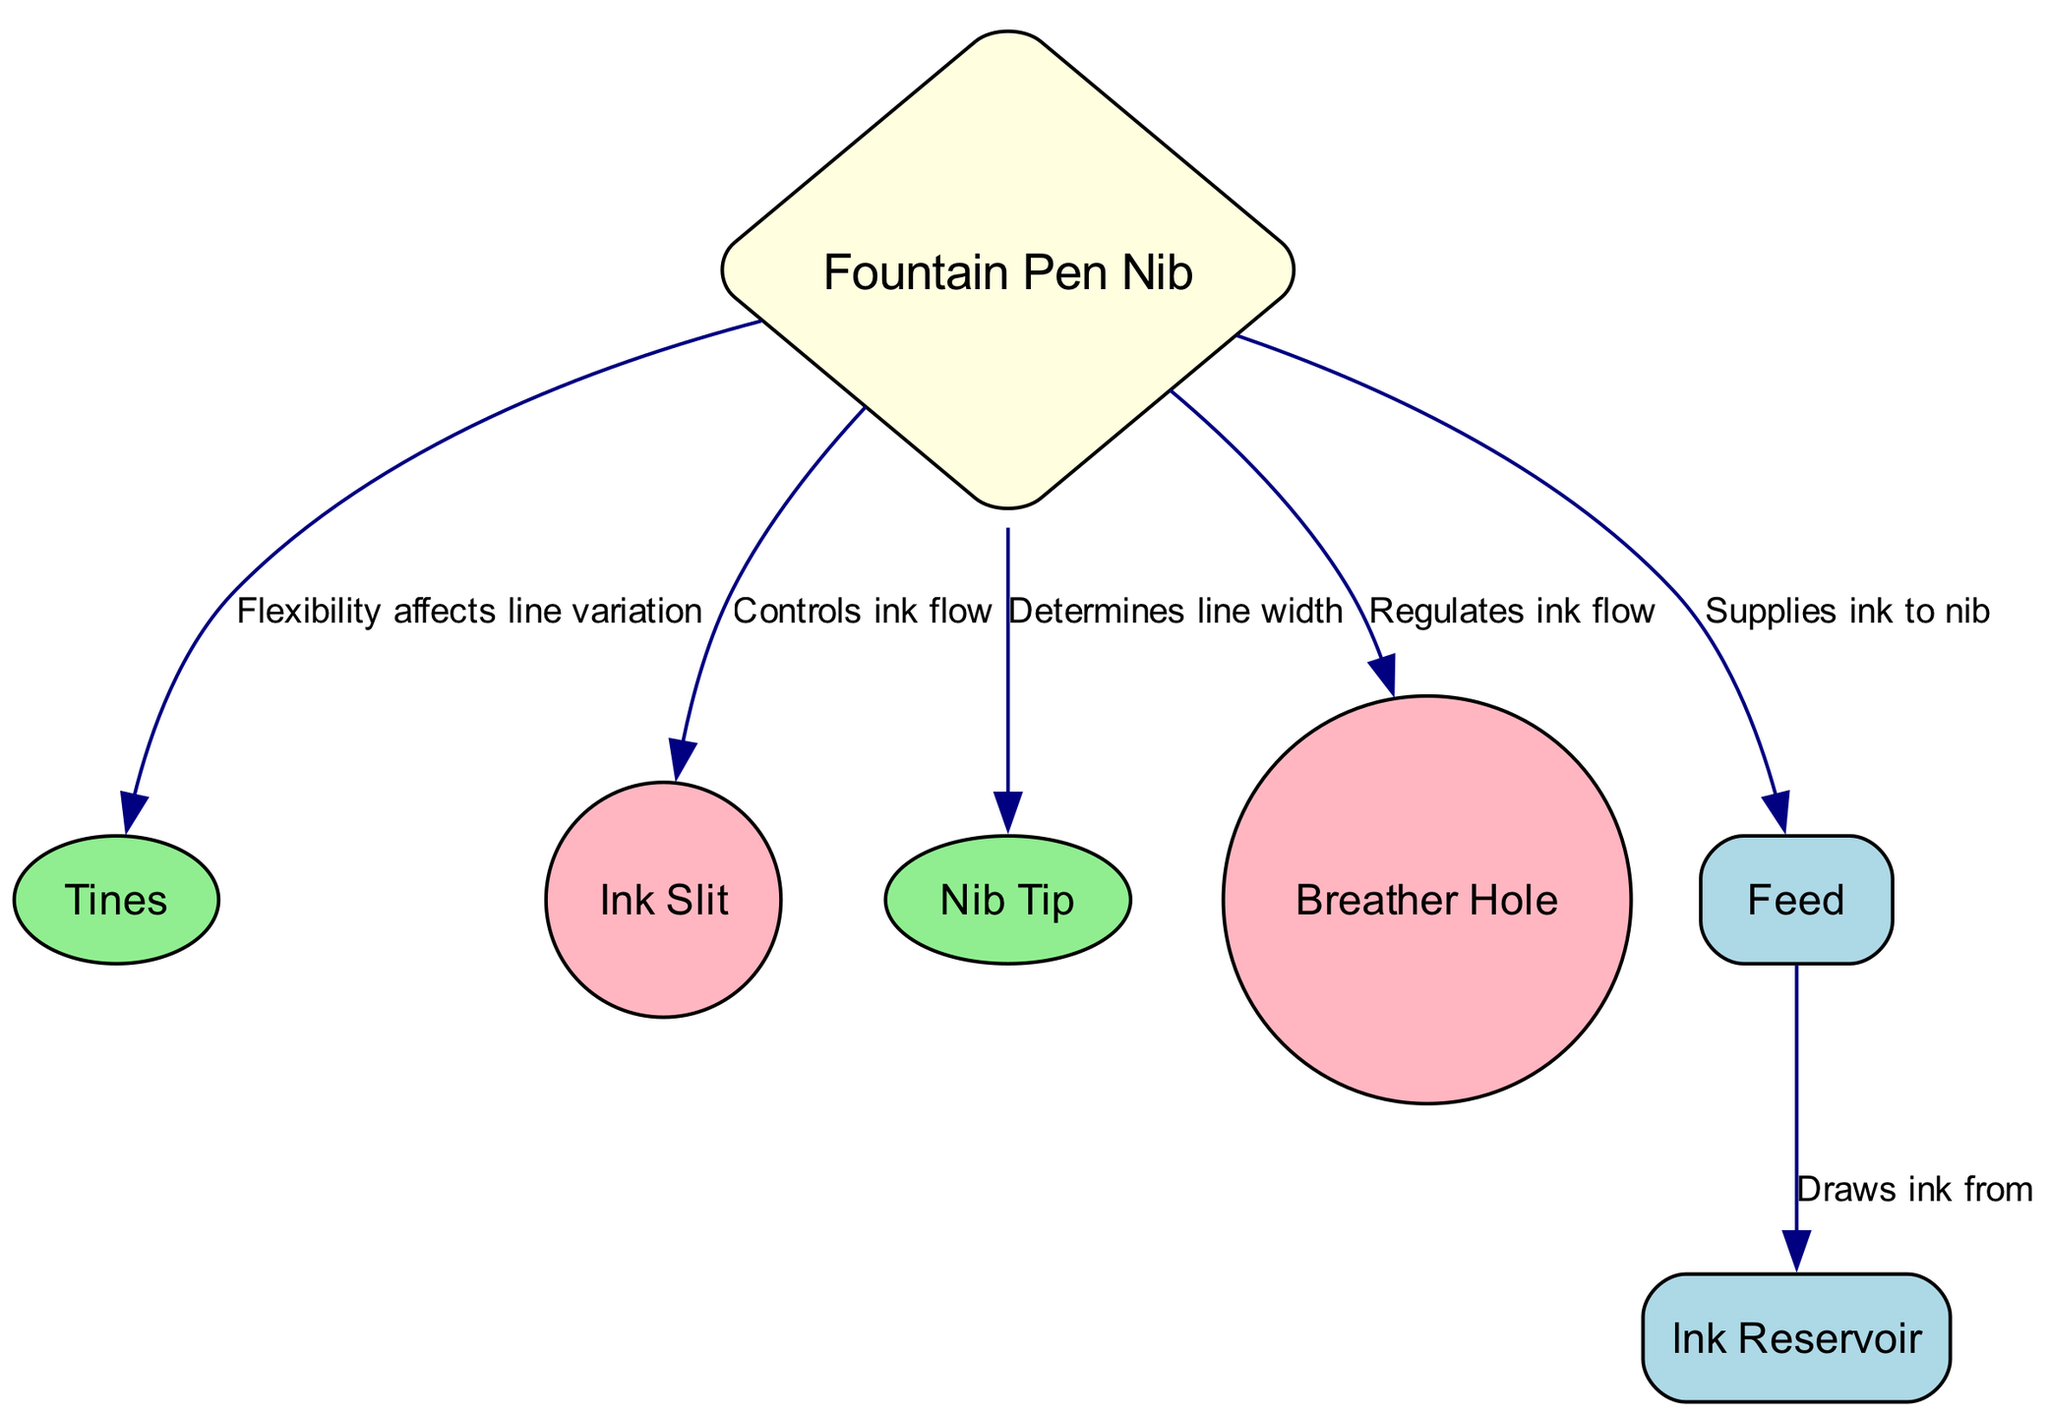What is the main component of the diagram? The main component is marked as "Fountain Pen Nib," which serves as the primary focus in the diagram.
Answer: Fountain Pen Nib How many nodes are in the diagram? Counting all nodes in the diagram, we find that there are seven separate components represented as nodes.
Answer: 7 What does the breather hole regulate? The label on the edge connecting to the breather hole states that it regulates ink flow, indicating its functionality in the operation of the nib.
Answer: Ink flow Which part determines the line width? The edge connecting to the nib clearly states that the "Nib Tip" determines the line width, making it the specific component responsible for this feature.
Answer: Nib Tip How does the feed supply ink to the nib? The feed supplies ink by drawing it from the ink reservoir, as indicated by the connecting edge that describes the action between these two components.
Answer: Draws ink from Which component affects line variation? The diagram states that the tines affect line variation, highlighting their role in the flexibility and various line styles created while writing.
Answer: Tines What shape is the cross-section of the nib? The diagram uses a diamond shape for the nib, differentiating it from other parts, which are represented in various shapes to indicate their different functions.
Answer: Diamond How many edges connect to the nib? The diagram displays five edges that connect to the nib, showcasing its various connections to other components that influence its performance and ink flow.
Answer: 5 What function does the ink slit control? According to the diagram, the ink slit controls the ink flow, indicating that it is a crucial part of the nib's functionality.
Answer: Ink flow 